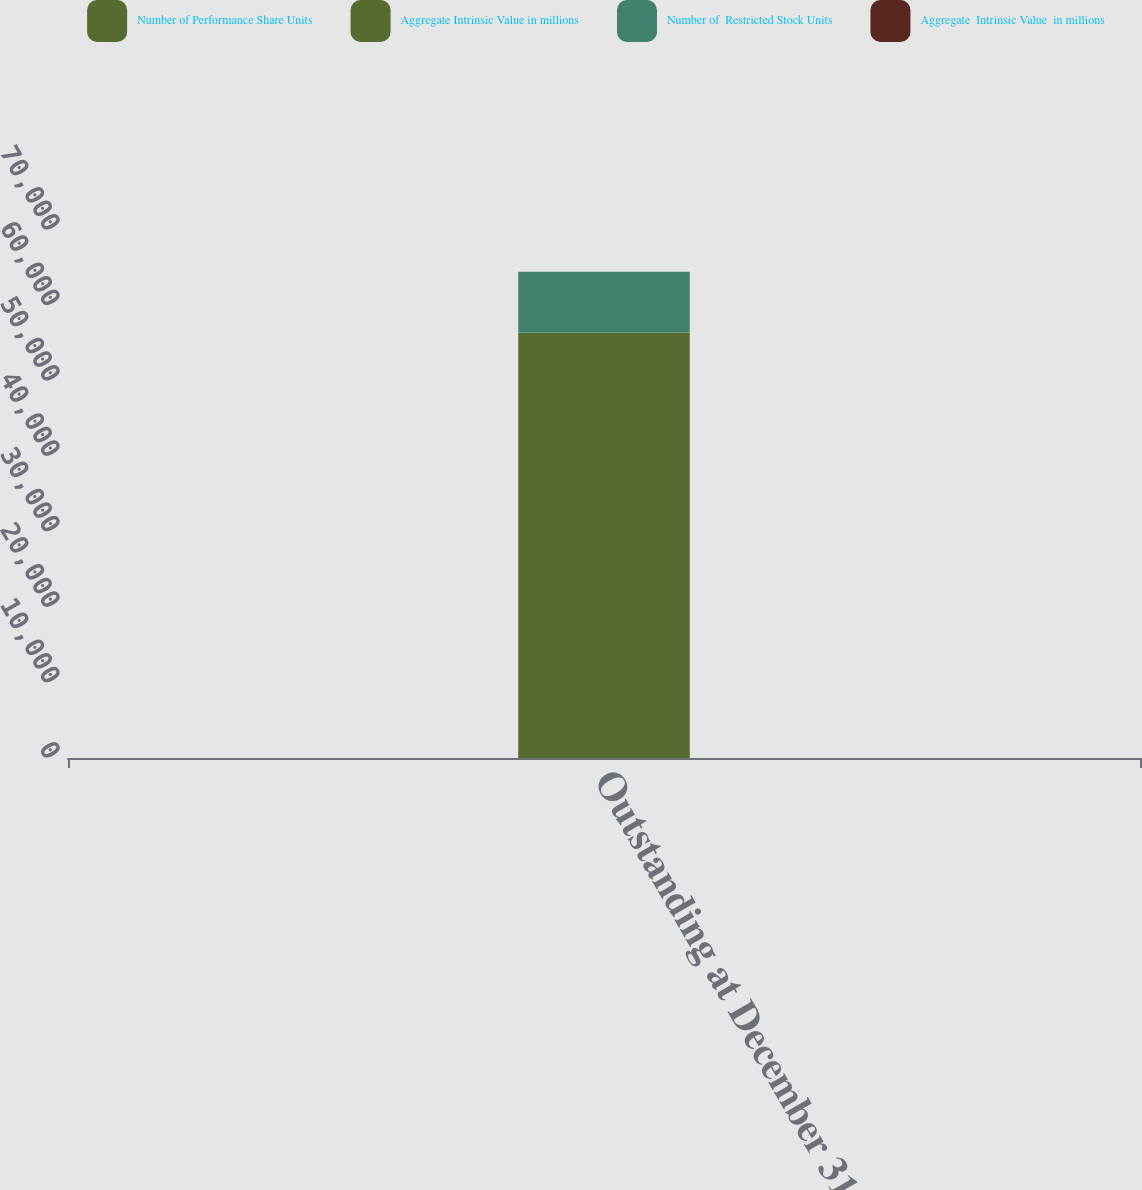<chart> <loc_0><loc_0><loc_500><loc_500><stacked_bar_chart><ecel><fcel>Outstanding at December 31<nl><fcel>Number of Performance Share Units<fcel>56389<nl><fcel>Aggregate Intrinsic Value in millions<fcel>34.9<nl><fcel>Number of  Restricted Stock Units<fcel>8050<nl><fcel>Aggregate  Intrinsic Value  in millions<fcel>5<nl></chart> 